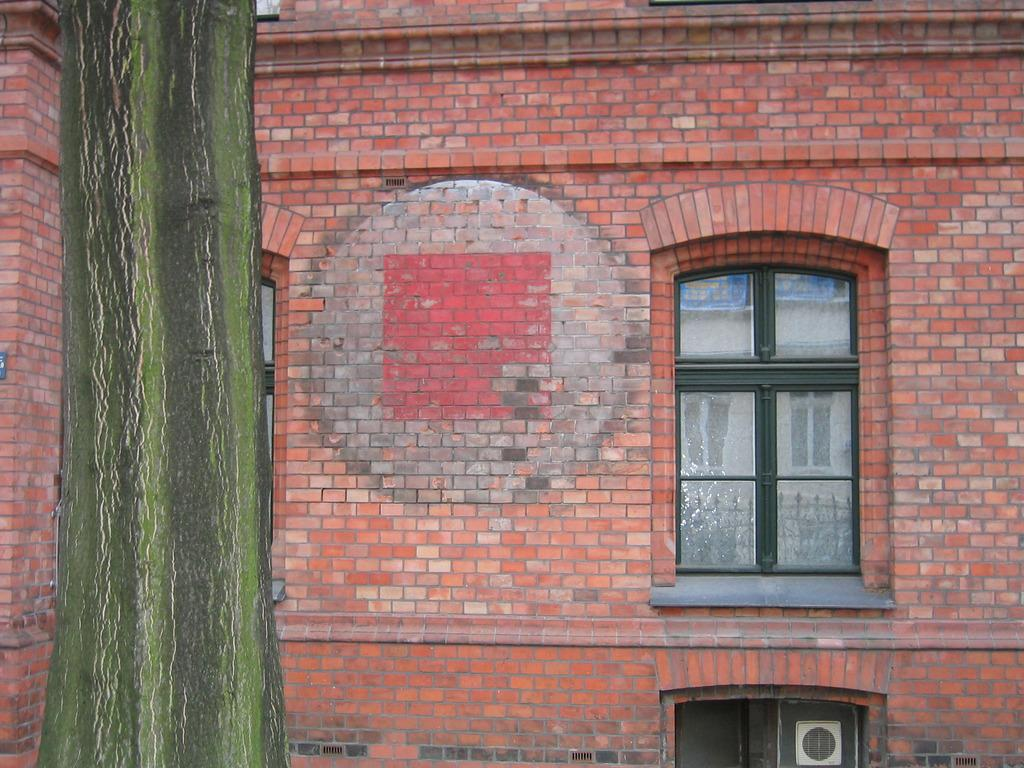What type of structure is visible in the image? There is a brick wall in the image. What architectural features can be seen in the brick wall? There are windows visible in the brick wall. What natural element is present in the image? The trunk of a tree is visible towards the left side of the image. What type of patch can be seen on the wall in the image? There is no patch visible on the wall in the image. What scent is emanating from the tree trunk in the image? There is no mention of any scent in the image, and the tree trunk is not described in detail. 